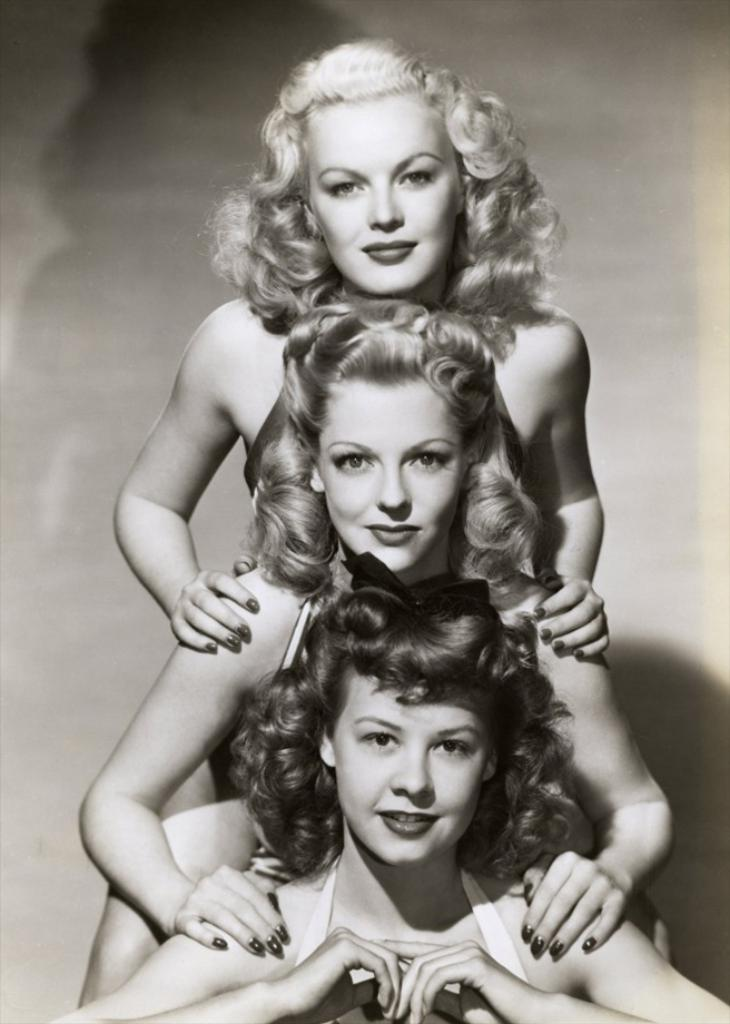How many people are in the image? There are three women in the image. What is the facial expression of the women in the image? The women are smiling. What color mode is the image in? The image is in black and white mode. What type of design is featured on the yoke of the parent in the image? There is no yoke or parent present in the image; it features three women who are smiling. 